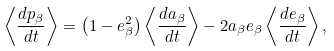<formula> <loc_0><loc_0><loc_500><loc_500>\left \langle \frac { d p _ { \beta } } { d t } \right \rangle = \left ( 1 - e _ { \beta } ^ { 2 } \right ) \left \langle \frac { d a _ { \beta } } { d t } \right \rangle - 2 a _ { \beta } e _ { \beta } \left \langle \frac { d e _ { \beta } } { d t } \right \rangle ,</formula> 